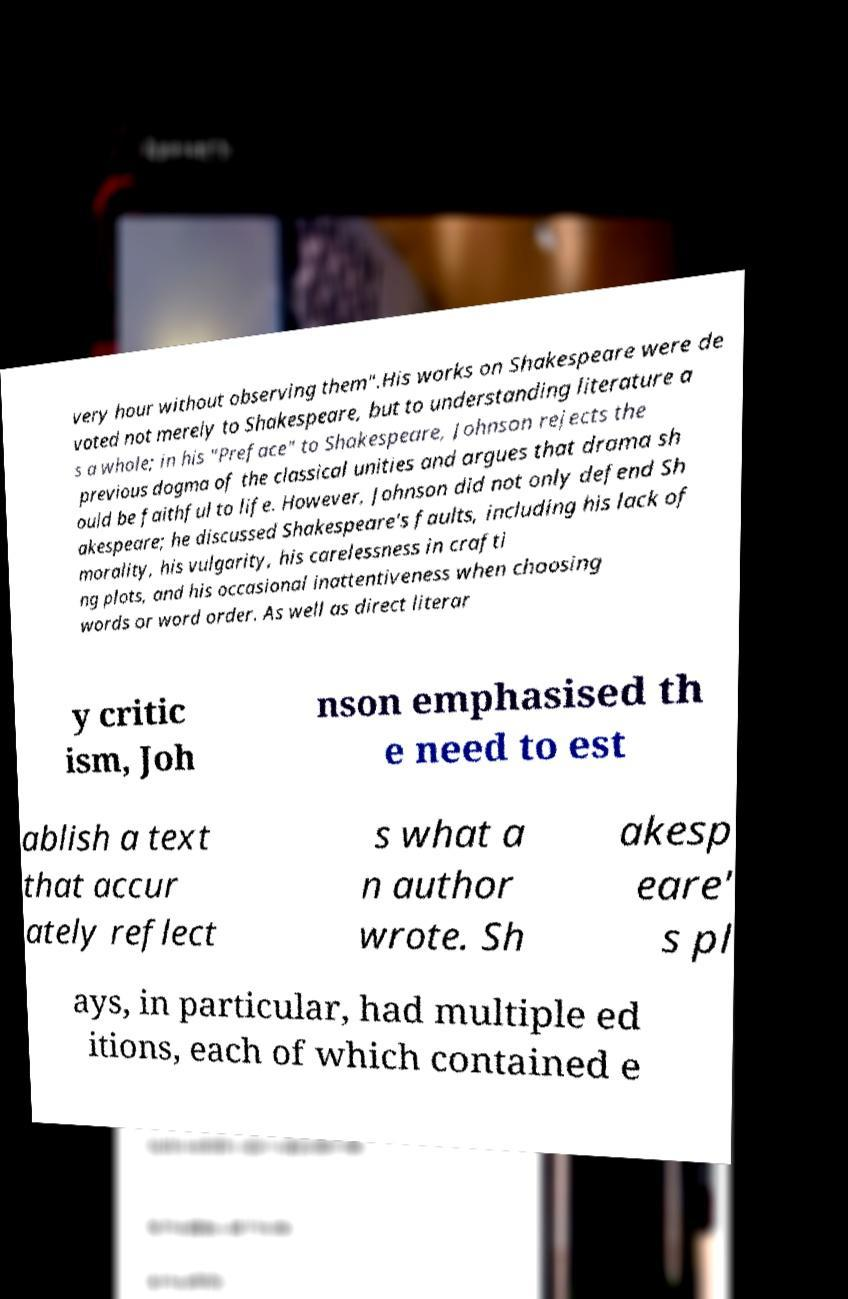For documentation purposes, I need the text within this image transcribed. Could you provide that? very hour without observing them".His works on Shakespeare were de voted not merely to Shakespeare, but to understanding literature a s a whole; in his "Preface" to Shakespeare, Johnson rejects the previous dogma of the classical unities and argues that drama sh ould be faithful to life. However, Johnson did not only defend Sh akespeare; he discussed Shakespeare's faults, including his lack of morality, his vulgarity, his carelessness in crafti ng plots, and his occasional inattentiveness when choosing words or word order. As well as direct literar y critic ism, Joh nson emphasised th e need to est ablish a text that accur ately reflect s what a n author wrote. Sh akesp eare' s pl ays, in particular, had multiple ed itions, each of which contained e 